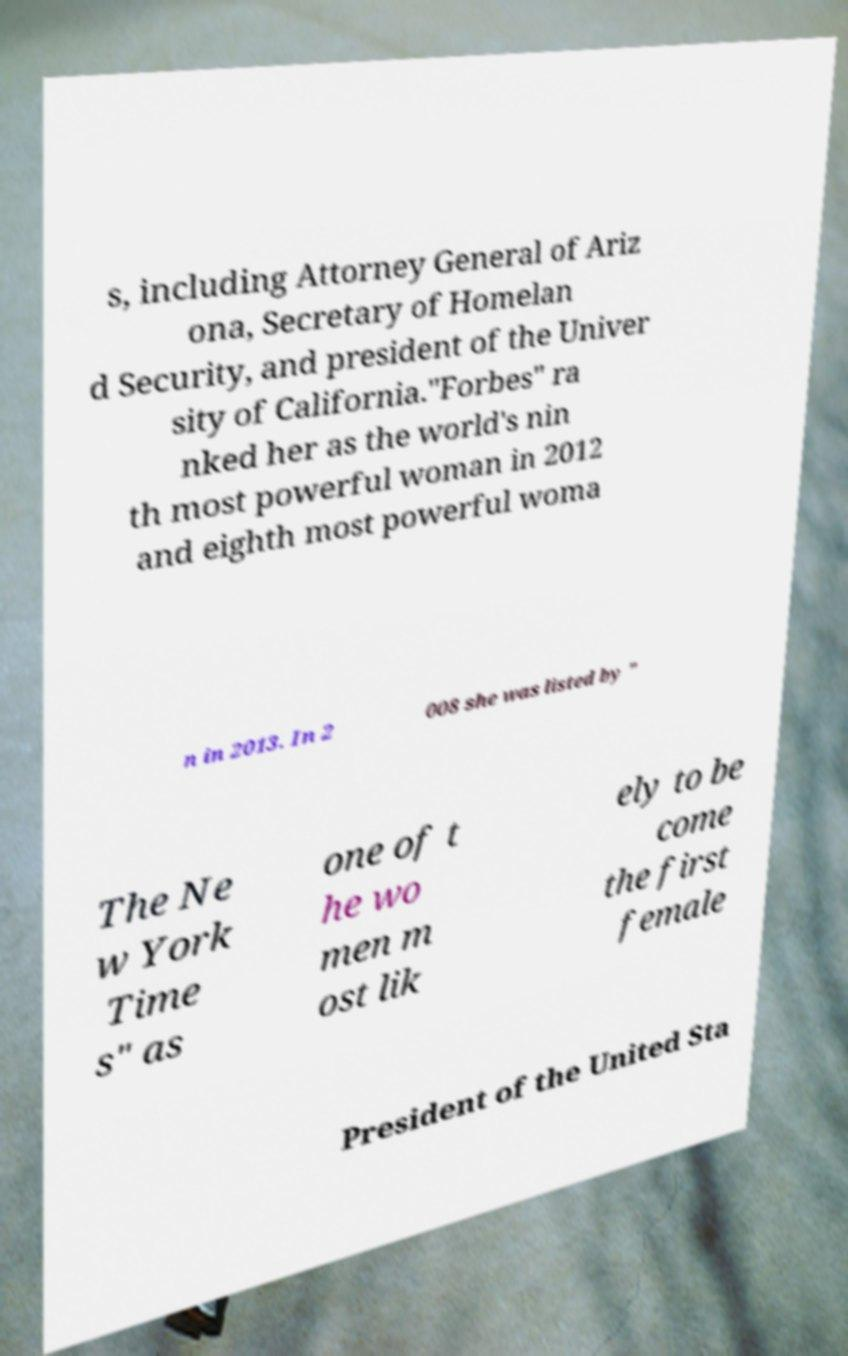Could you assist in decoding the text presented in this image and type it out clearly? s, including Attorney General of Ariz ona, Secretary of Homelan d Security, and president of the Univer sity of California."Forbes" ra nked her as the world's nin th most powerful woman in 2012 and eighth most powerful woma n in 2013. In 2 008 she was listed by " The Ne w York Time s" as one of t he wo men m ost lik ely to be come the first female President of the United Sta 